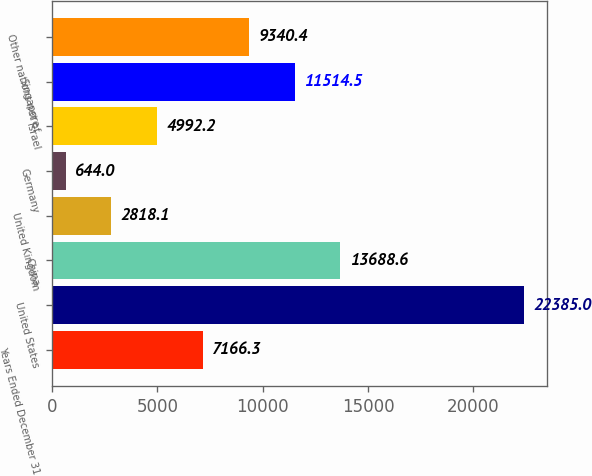Convert chart. <chart><loc_0><loc_0><loc_500><loc_500><bar_chart><fcel>Years Ended December 31<fcel>United States<fcel>China<fcel>United Kingdom<fcel>Germany<fcel>Israel<fcel>Singapore<fcel>Other nations net of<nl><fcel>7166.3<fcel>22385<fcel>13688.6<fcel>2818.1<fcel>644<fcel>4992.2<fcel>11514.5<fcel>9340.4<nl></chart> 